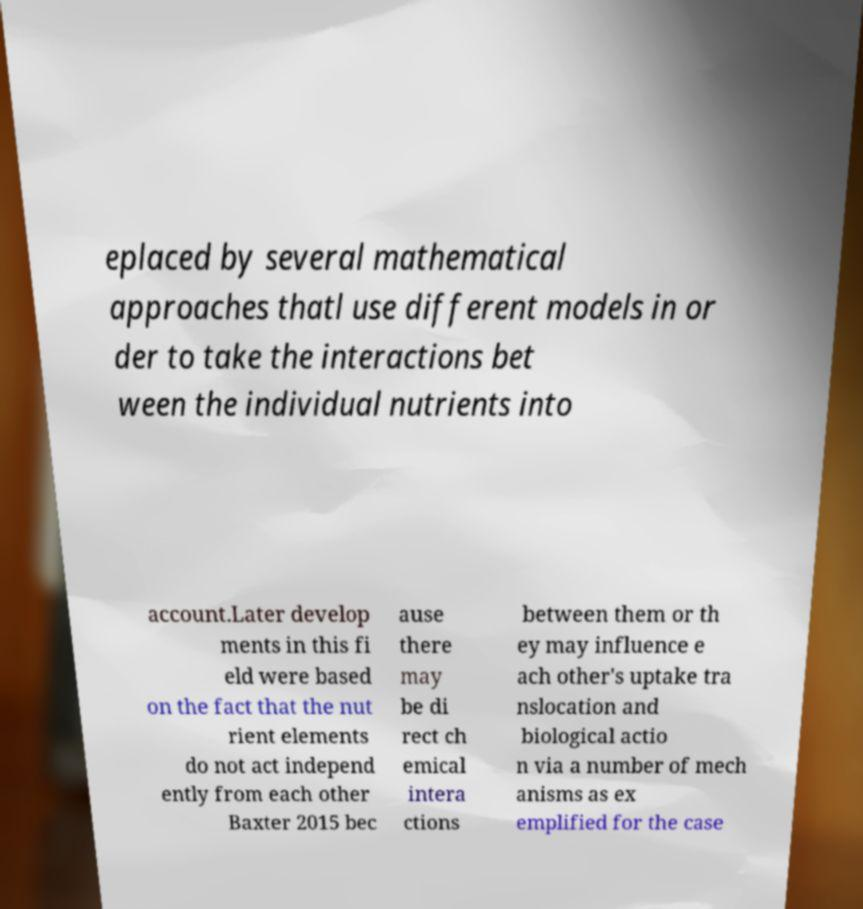Can you read and provide the text displayed in the image?This photo seems to have some interesting text. Can you extract and type it out for me? eplaced by several mathematical approaches thatl use different models in or der to take the interactions bet ween the individual nutrients into account.Later develop ments in this fi eld were based on the fact that the nut rient elements do not act independ ently from each other Baxter 2015 bec ause there may be di rect ch emical intera ctions between them or th ey may influence e ach other's uptake tra nslocation and biological actio n via a number of mech anisms as ex emplified for the case 